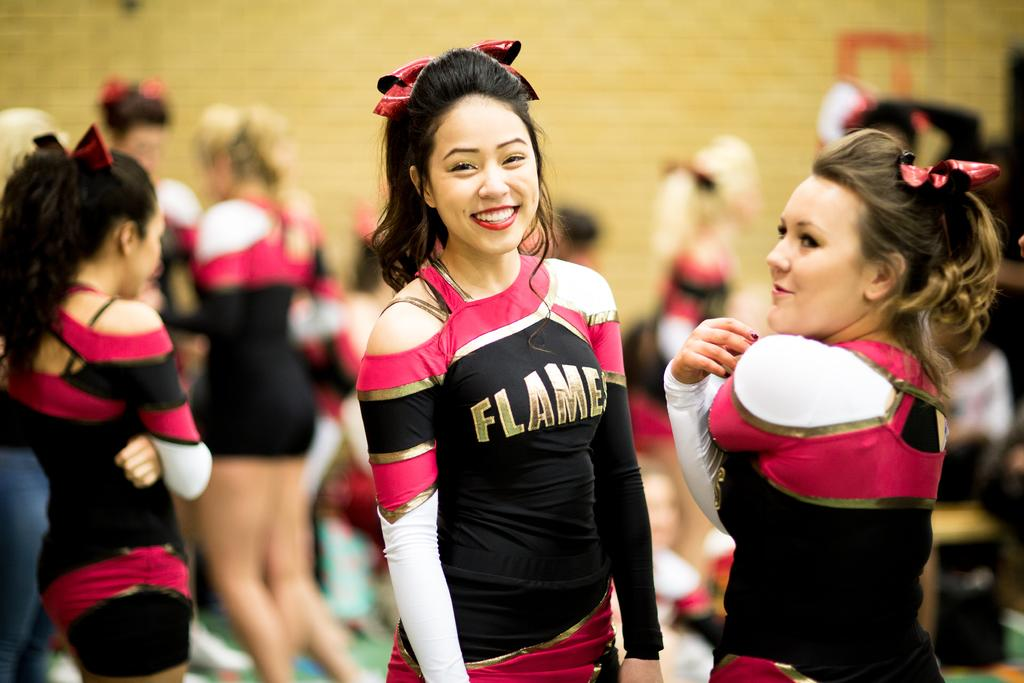Provide a one-sentence caption for the provided image. A group of cheerleaders have the word "Flames" written on their uniforms. 